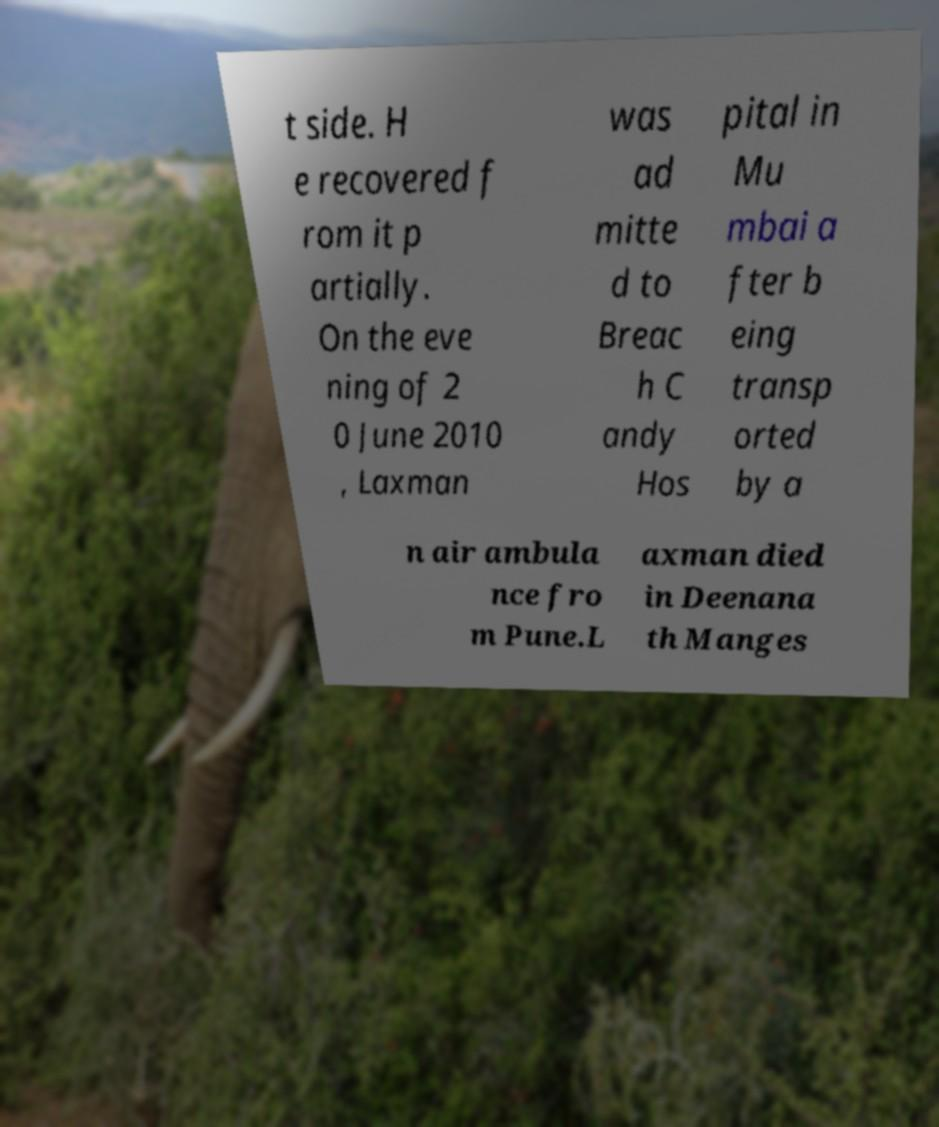What messages or text are displayed in this image? I need them in a readable, typed format. t side. H e recovered f rom it p artially. On the eve ning of 2 0 June 2010 , Laxman was ad mitte d to Breac h C andy Hos pital in Mu mbai a fter b eing transp orted by a n air ambula nce fro m Pune.L axman died in Deenana th Manges 